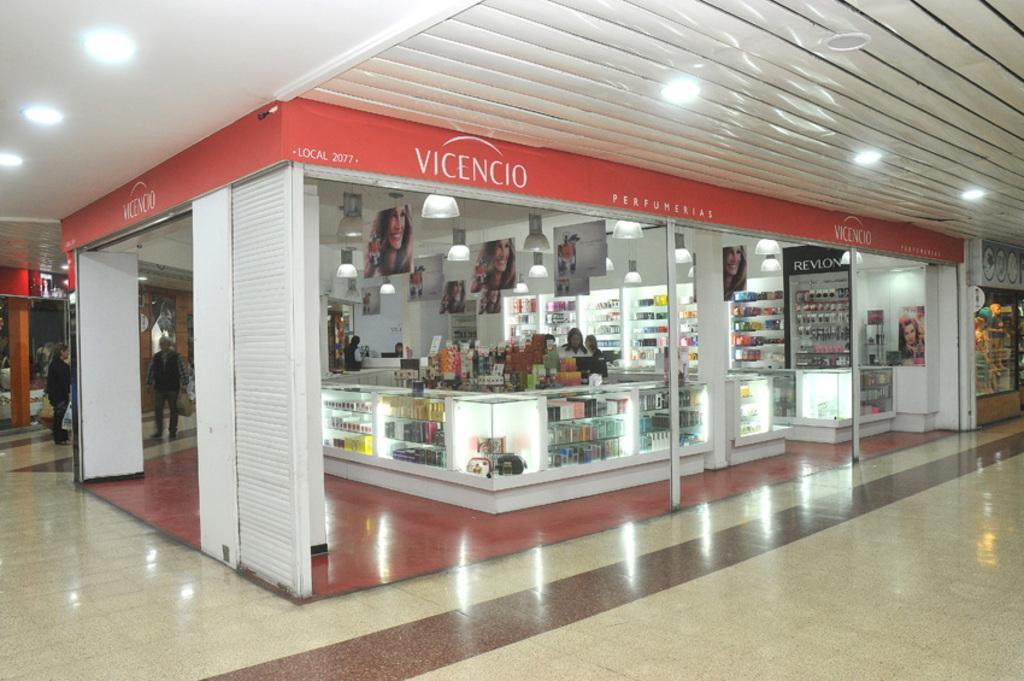Can you describe this image briefly? In this image in the middle, there is a building, shop on that shop there are many lights, posters, accessories and some people. On the left there is a woman, she wears a t shirt, trouser and in front of her there is a man, he wears a jacket, trouser. At the top there are lights. At the the bottom there is floor. 